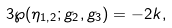<formula> <loc_0><loc_0><loc_500><loc_500>3 \wp ( \eta _ { 1 , 2 } ; g _ { 2 } , g _ { 3 } ) = - 2 k ,</formula> 